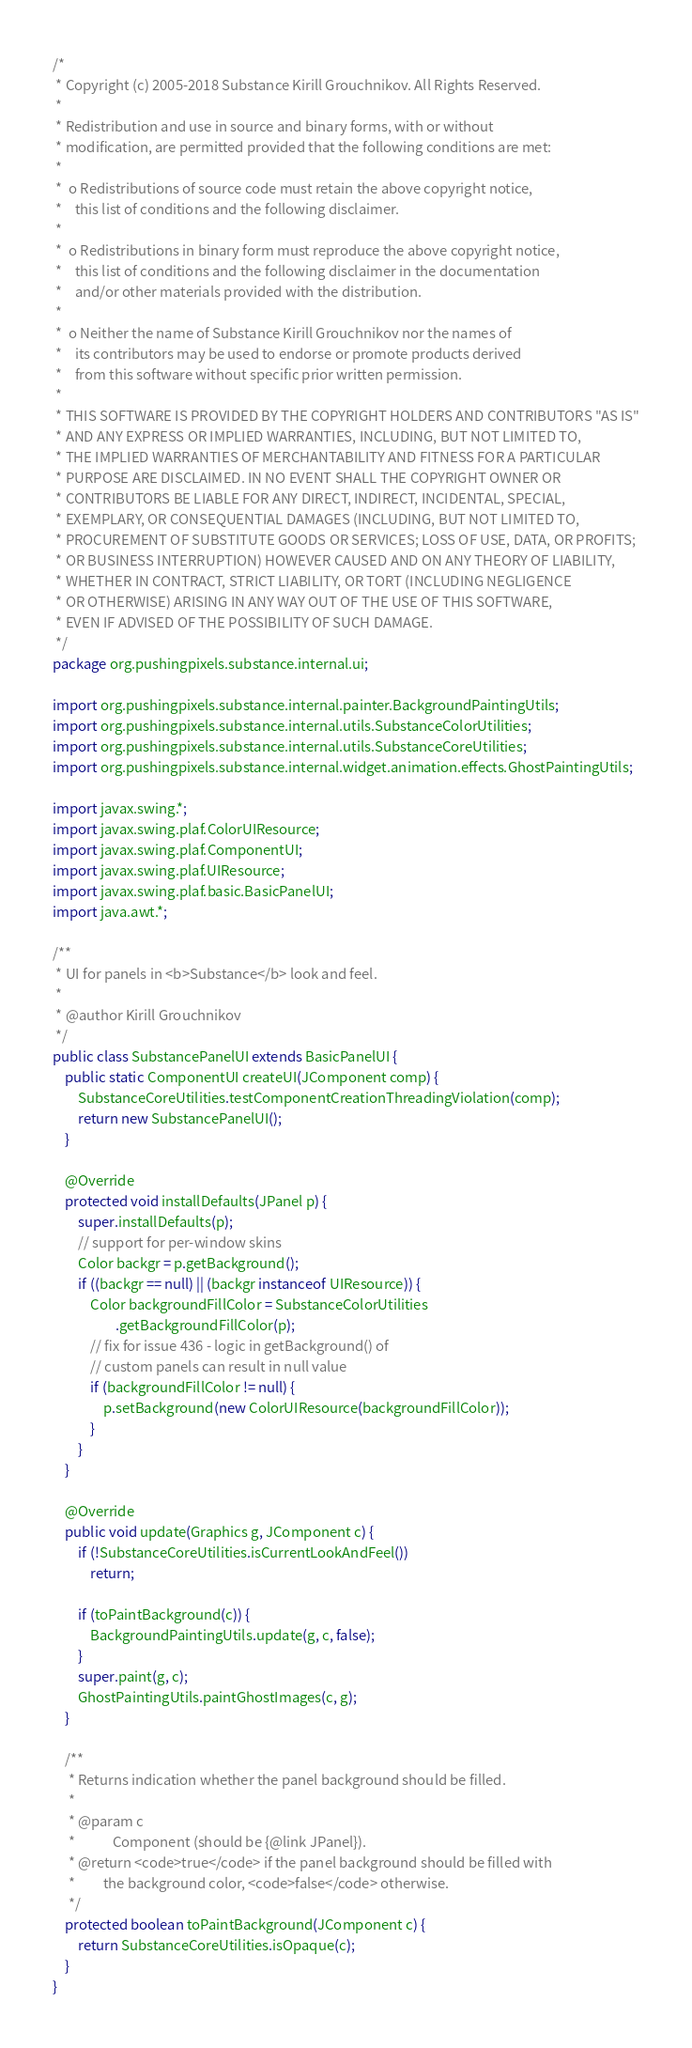Convert code to text. <code><loc_0><loc_0><loc_500><loc_500><_Java_>/*
 * Copyright (c) 2005-2018 Substance Kirill Grouchnikov. All Rights Reserved.
 *
 * Redistribution and use in source and binary forms, with or without
 * modification, are permitted provided that the following conditions are met:
 *
 *  o Redistributions of source code must retain the above copyright notice,
 *    this list of conditions and the following disclaimer.
 *
 *  o Redistributions in binary form must reproduce the above copyright notice,
 *    this list of conditions and the following disclaimer in the documentation
 *    and/or other materials provided with the distribution.
 *
 *  o Neither the name of Substance Kirill Grouchnikov nor the names of
 *    its contributors may be used to endorse or promote products derived
 *    from this software without specific prior written permission.
 *
 * THIS SOFTWARE IS PROVIDED BY THE COPYRIGHT HOLDERS AND CONTRIBUTORS "AS IS"
 * AND ANY EXPRESS OR IMPLIED WARRANTIES, INCLUDING, BUT NOT LIMITED TO,
 * THE IMPLIED WARRANTIES OF MERCHANTABILITY AND FITNESS FOR A PARTICULAR
 * PURPOSE ARE DISCLAIMED. IN NO EVENT SHALL THE COPYRIGHT OWNER OR
 * CONTRIBUTORS BE LIABLE FOR ANY DIRECT, INDIRECT, INCIDENTAL, SPECIAL,
 * EXEMPLARY, OR CONSEQUENTIAL DAMAGES (INCLUDING, BUT NOT LIMITED TO,
 * PROCUREMENT OF SUBSTITUTE GOODS OR SERVICES; LOSS OF USE, DATA, OR PROFITS;
 * OR BUSINESS INTERRUPTION) HOWEVER CAUSED AND ON ANY THEORY OF LIABILITY,
 * WHETHER IN CONTRACT, STRICT LIABILITY, OR TORT (INCLUDING NEGLIGENCE
 * OR OTHERWISE) ARISING IN ANY WAY OUT OF THE USE OF THIS SOFTWARE,
 * EVEN IF ADVISED OF THE POSSIBILITY OF SUCH DAMAGE.
 */
package org.pushingpixels.substance.internal.ui;

import org.pushingpixels.substance.internal.painter.BackgroundPaintingUtils;
import org.pushingpixels.substance.internal.utils.SubstanceColorUtilities;
import org.pushingpixels.substance.internal.utils.SubstanceCoreUtilities;
import org.pushingpixels.substance.internal.widget.animation.effects.GhostPaintingUtils;

import javax.swing.*;
import javax.swing.plaf.ColorUIResource;
import javax.swing.plaf.ComponentUI;
import javax.swing.plaf.UIResource;
import javax.swing.plaf.basic.BasicPanelUI;
import java.awt.*;

/**
 * UI for panels in <b>Substance</b> look and feel.
 * 
 * @author Kirill Grouchnikov
 */
public class SubstancePanelUI extends BasicPanelUI {
	public static ComponentUI createUI(JComponent comp) {
		SubstanceCoreUtilities.testComponentCreationThreadingViolation(comp);
		return new SubstancePanelUI();
	}

	@Override
	protected void installDefaults(JPanel p) {
		super.installDefaults(p);
		// support for per-window skins
		Color backgr = p.getBackground();
		if ((backgr == null) || (backgr instanceof UIResource)) {
			Color backgroundFillColor = SubstanceColorUtilities
					.getBackgroundFillColor(p);
			// fix for issue 436 - logic in getBackground() of
			// custom panels can result in null value
			if (backgroundFillColor != null) {
				p.setBackground(new ColorUIResource(backgroundFillColor));
			}
		}
	}

	@Override
	public void update(Graphics g, JComponent c) {
		if (!SubstanceCoreUtilities.isCurrentLookAndFeel())
			return;

		if (toPaintBackground(c)) {
			BackgroundPaintingUtils.update(g, c, false);
		}
		super.paint(g, c);
		GhostPaintingUtils.paintGhostImages(c, g);
	}

	/**
	 * Returns indication whether the panel background should be filled.
	 * 
	 * @param c
	 *            Component (should be {@link JPanel}).
	 * @return <code>true</code> if the panel background should be filled with
	 *         the background color, <code>false</code> otherwise.
	 */
	protected boolean toPaintBackground(JComponent c) {
		return SubstanceCoreUtilities.isOpaque(c);
	}
}
</code> 